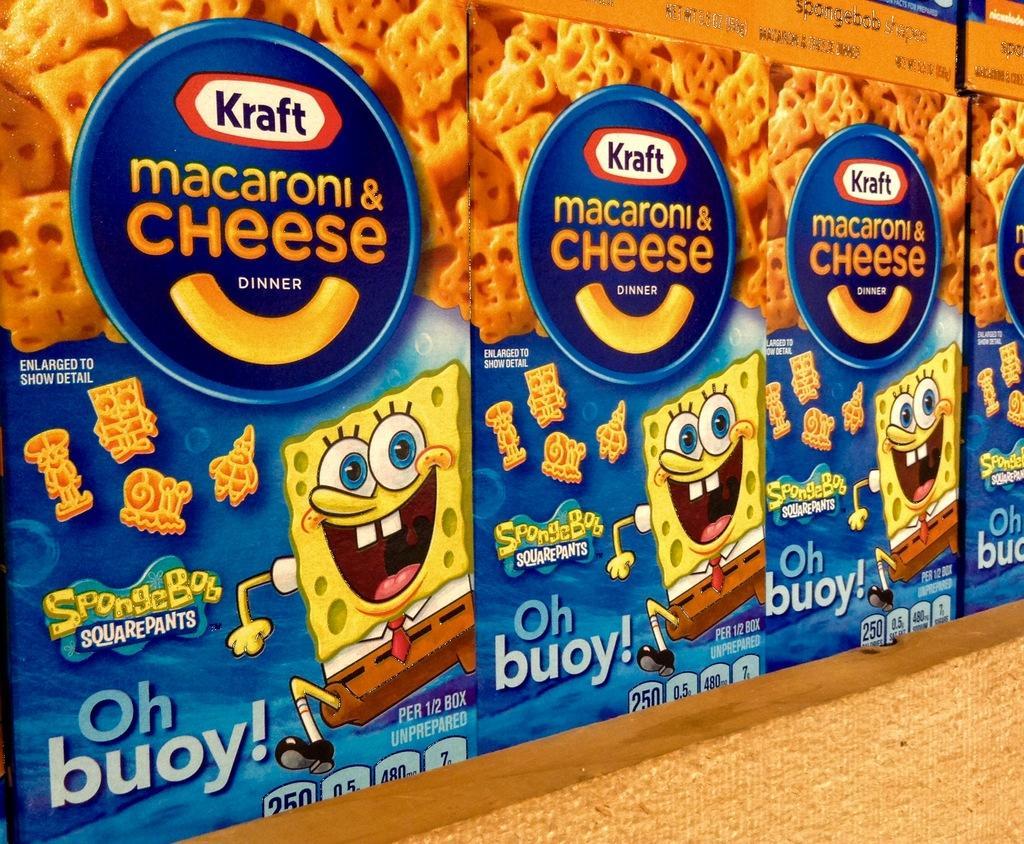How would you summarize this image in a sentence or two? In the image we can see these are the boxes, on the box there is a printed text, animated pictures and view of the food item. 